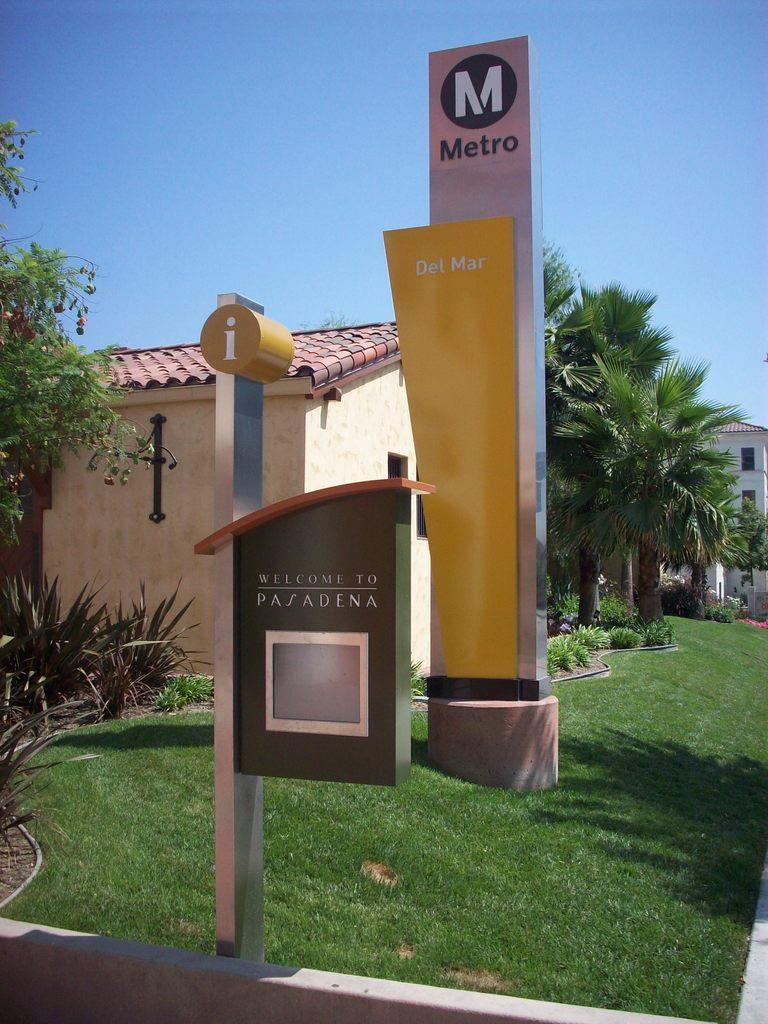What type of structures can be seen in the image? There are buildings in the image. What architectural features can be observed on the buildings? There are windows visible on the buildings. What type of vegetation is present in the image? There are trees and grass in the image. What other objects can be seen in the image? There are boards in the image. What is visible in the background of the image? The sky is visible in the image. What type of poison is being used to clean the windows in the image? There is no poison present in the image, and windows are not being cleaned. Can you tell me how many notebooks are on the grass in the image? There are no notebooks present in the image. 